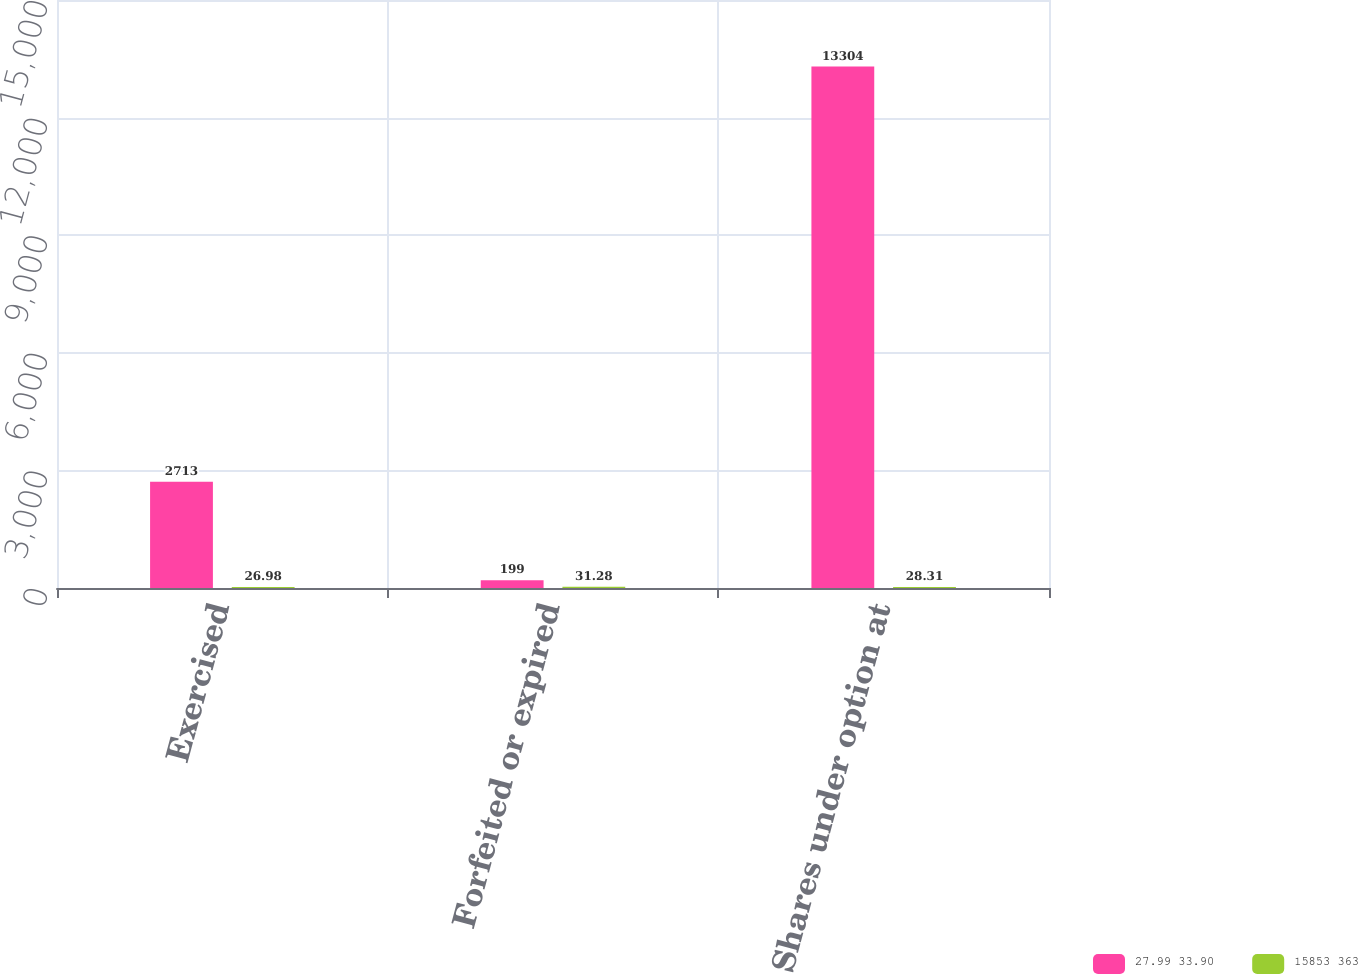<chart> <loc_0><loc_0><loc_500><loc_500><stacked_bar_chart><ecel><fcel>Exercised<fcel>Forfeited or expired<fcel>Shares under option at<nl><fcel>27.99 33.90<fcel>2713<fcel>199<fcel>13304<nl><fcel>15853 363<fcel>26.98<fcel>31.28<fcel>28.31<nl></chart> 